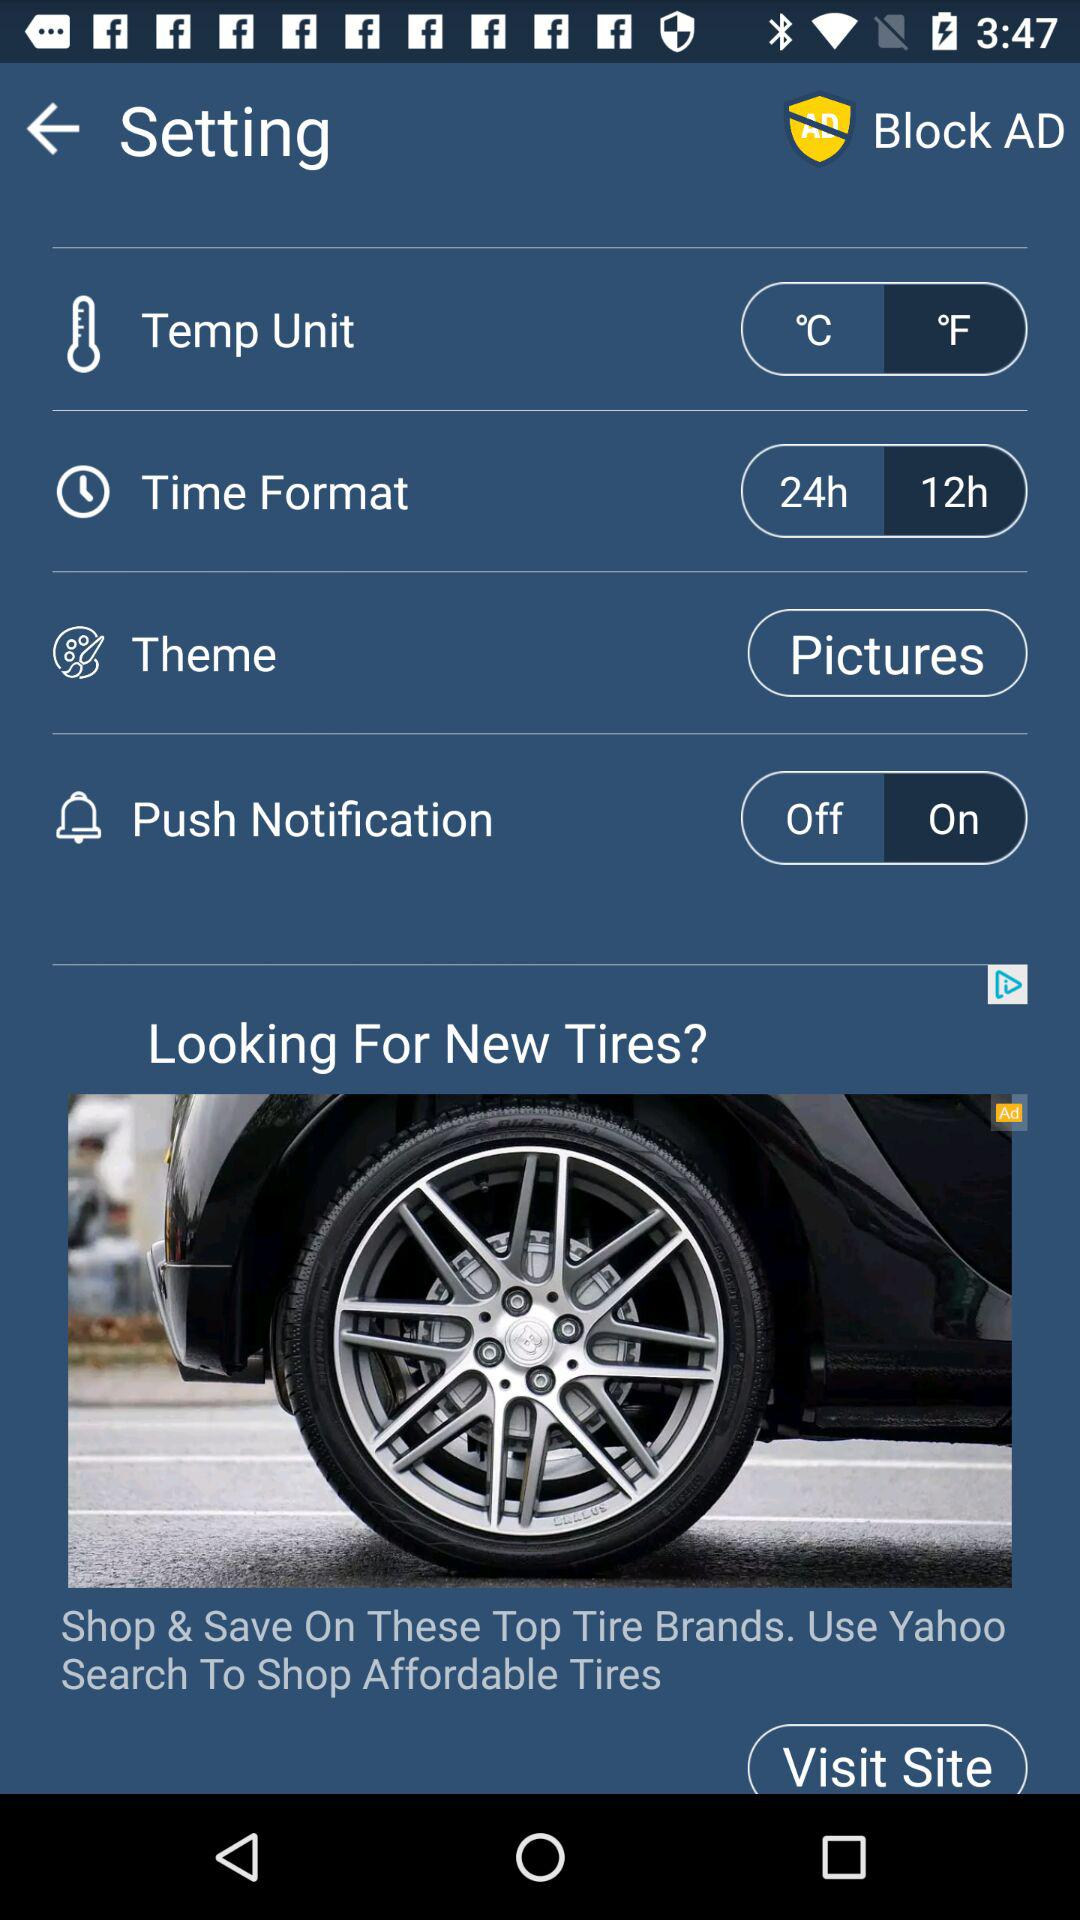What is the time format? The time format is 12 hours. 